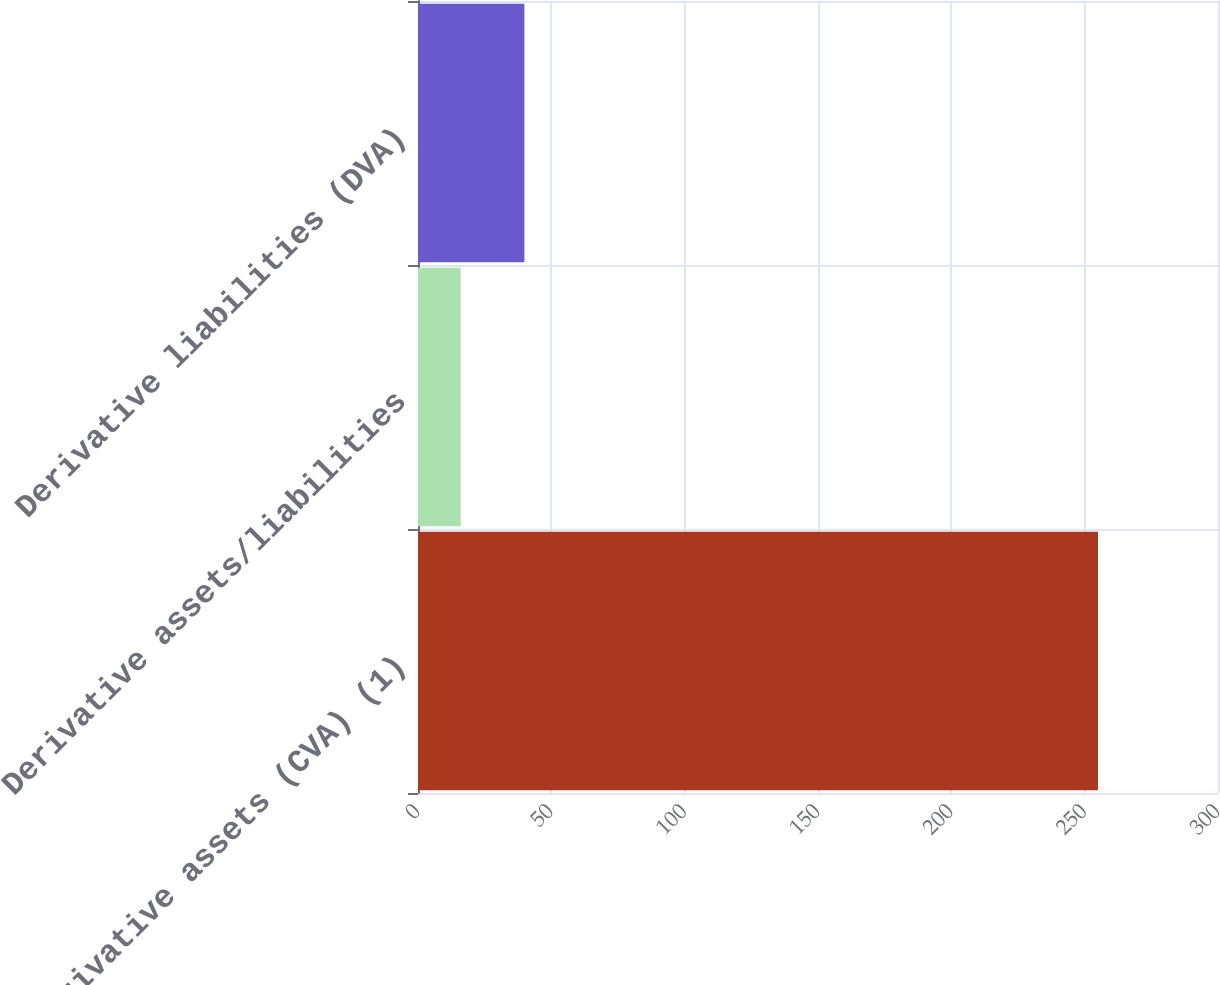<chart> <loc_0><loc_0><loc_500><loc_500><bar_chart><fcel>Derivative assets (CVA) (1)<fcel>Derivative assets/liabilities<fcel>Derivative liabilities (DVA)<nl><fcel>255<fcel>16<fcel>39.9<nl></chart> 